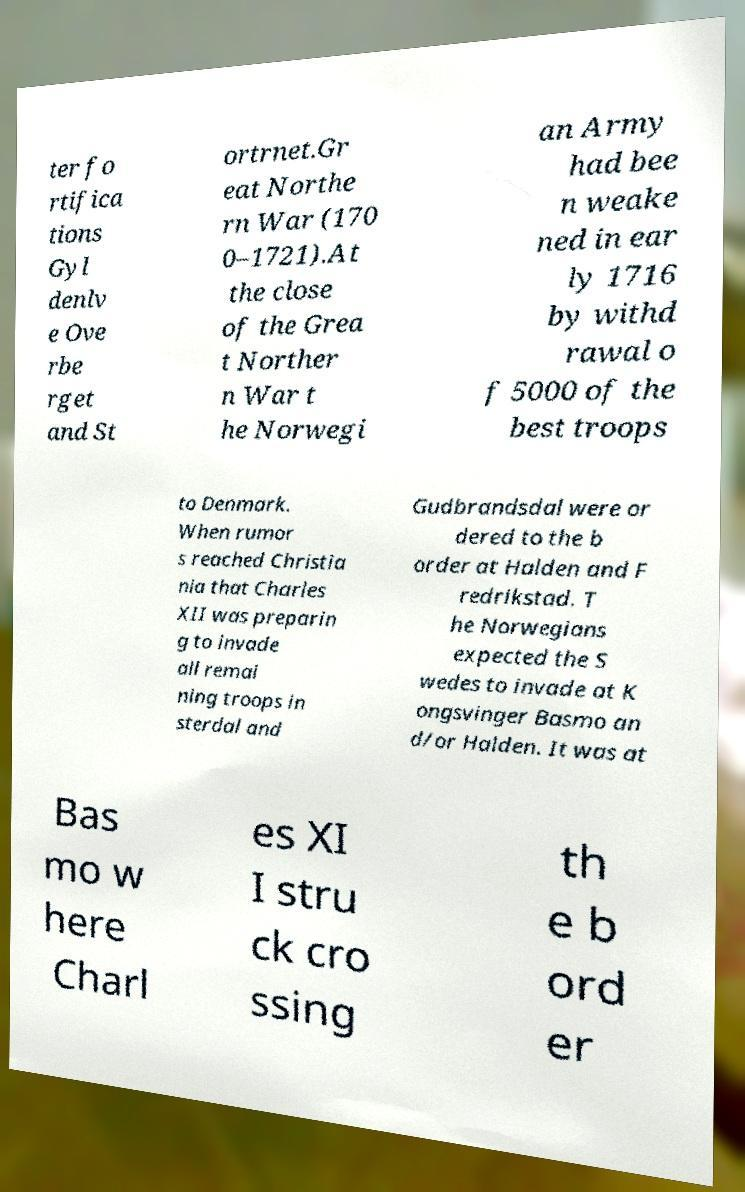There's text embedded in this image that I need extracted. Can you transcribe it verbatim? ter fo rtifica tions Gyl denlv e Ove rbe rget and St ortrnet.Gr eat Northe rn War (170 0–1721).At the close of the Grea t Norther n War t he Norwegi an Army had bee n weake ned in ear ly 1716 by withd rawal o f 5000 of the best troops to Denmark. When rumor s reached Christia nia that Charles XII was preparin g to invade all remai ning troops in sterdal and Gudbrandsdal were or dered to the b order at Halden and F redrikstad. T he Norwegians expected the S wedes to invade at K ongsvinger Basmo an d/or Halden. It was at Bas mo w here Charl es XI I stru ck cro ssing th e b ord er 